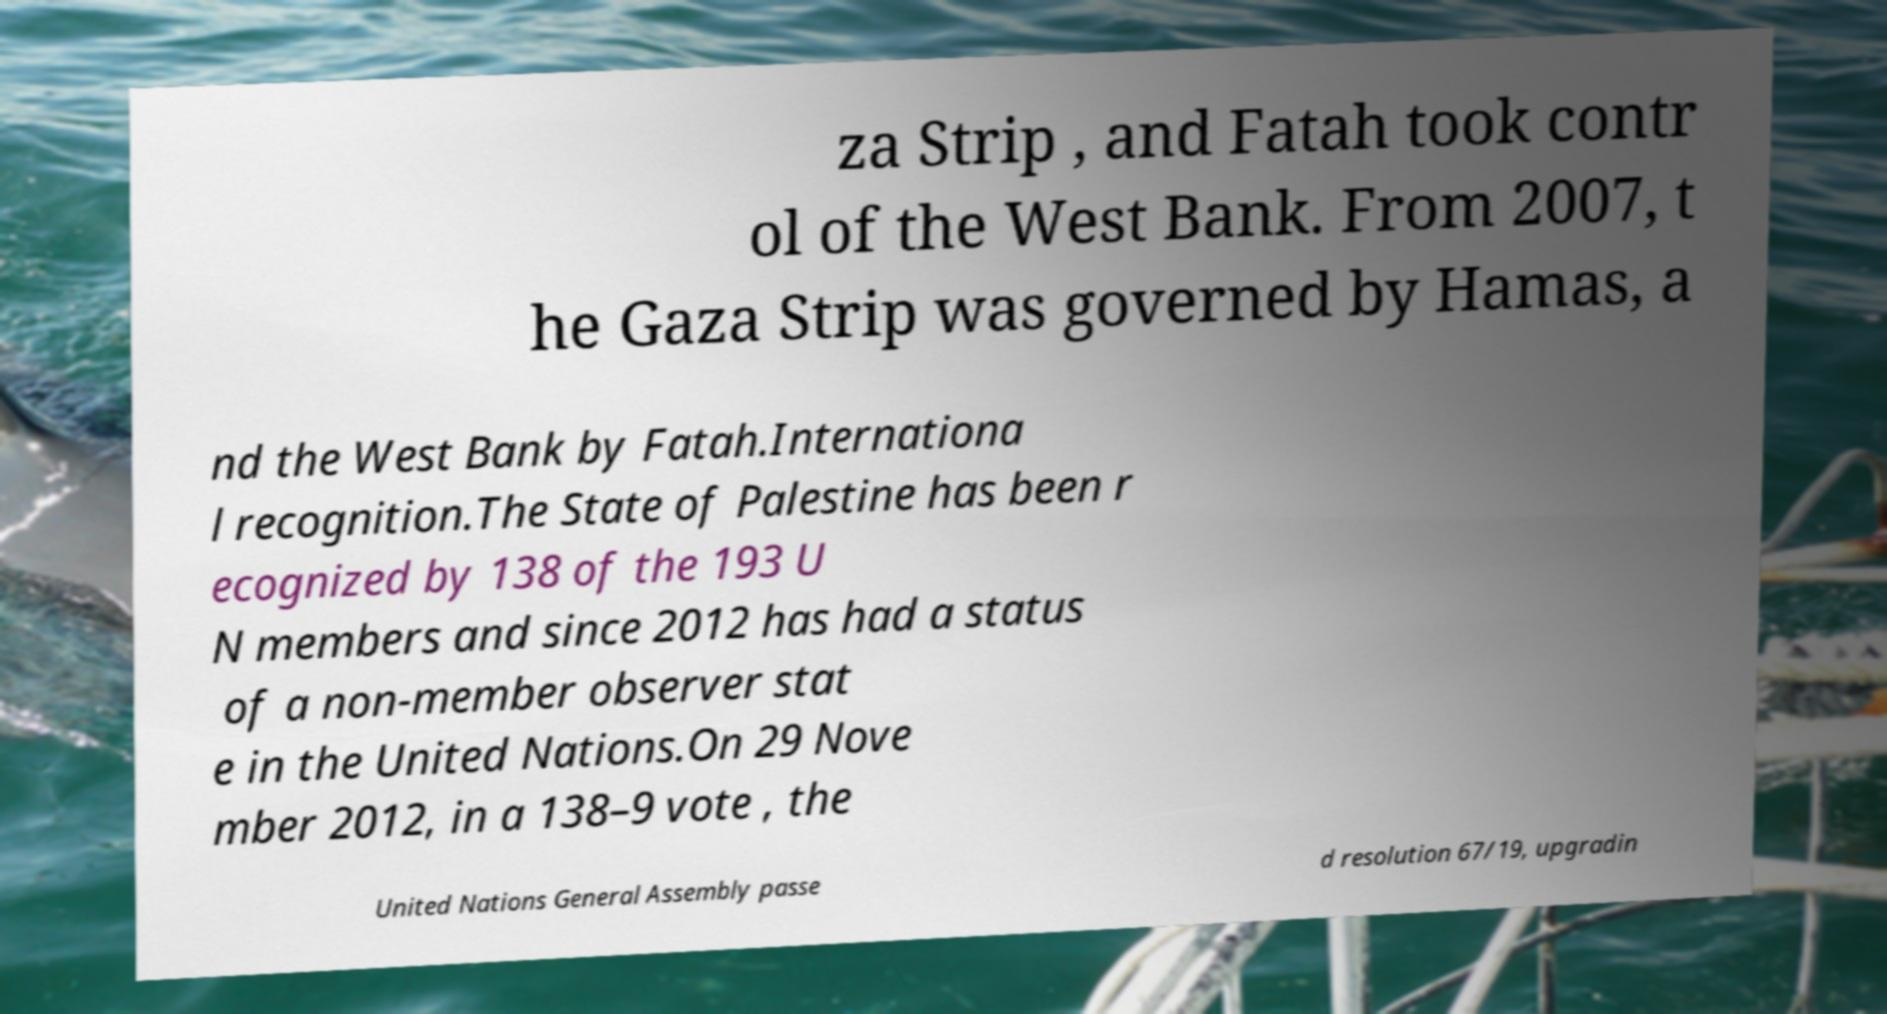Could you extract and type out the text from this image? za Strip , and Fatah took contr ol of the West Bank. From 2007, t he Gaza Strip was governed by Hamas, a nd the West Bank by Fatah.Internationa l recognition.The State of Palestine has been r ecognized by 138 of the 193 U N members and since 2012 has had a status of a non-member observer stat e in the United Nations.On 29 Nove mber 2012, in a 138–9 vote , the United Nations General Assembly passe d resolution 67/19, upgradin 